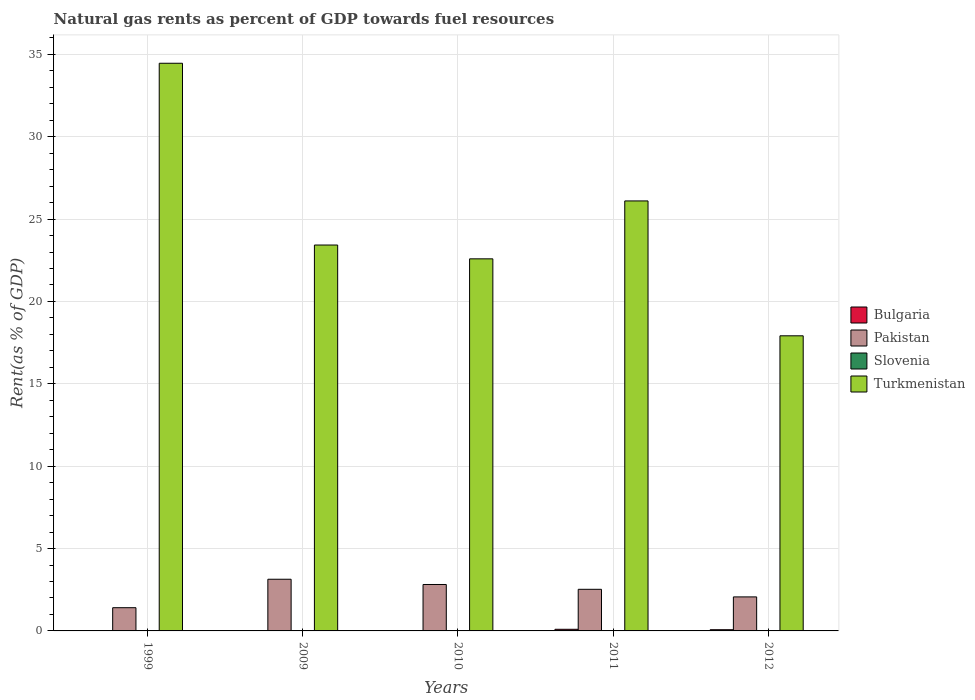How many different coloured bars are there?
Keep it short and to the point. 4. How many bars are there on the 5th tick from the left?
Your answer should be very brief. 4. What is the label of the 4th group of bars from the left?
Provide a short and direct response. 2011. What is the matural gas rent in Bulgaria in 1999?
Give a very brief answer. 0.01. Across all years, what is the maximum matural gas rent in Turkmenistan?
Keep it short and to the point. 34.46. Across all years, what is the minimum matural gas rent in Slovenia?
Give a very brief answer. 0. In which year was the matural gas rent in Slovenia maximum?
Your answer should be compact. 2010. In which year was the matural gas rent in Turkmenistan minimum?
Your answer should be very brief. 2012. What is the total matural gas rent in Slovenia in the graph?
Keep it short and to the point. 0. What is the difference between the matural gas rent in Pakistan in 2010 and that in 2011?
Offer a terse response. 0.29. What is the difference between the matural gas rent in Slovenia in 2010 and the matural gas rent in Bulgaria in 2012?
Offer a terse response. -0.07. What is the average matural gas rent in Bulgaria per year?
Give a very brief answer. 0.04. In the year 2010, what is the difference between the matural gas rent in Bulgaria and matural gas rent in Turkmenistan?
Offer a terse response. -22.57. In how many years, is the matural gas rent in Pakistan greater than 1 %?
Your response must be concise. 5. What is the ratio of the matural gas rent in Pakistan in 2010 to that in 2012?
Provide a short and direct response. 1.36. What is the difference between the highest and the second highest matural gas rent in Bulgaria?
Offer a terse response. 0.03. What is the difference between the highest and the lowest matural gas rent in Slovenia?
Keep it short and to the point. 0. What does the 3rd bar from the left in 2012 represents?
Give a very brief answer. Slovenia. Are all the bars in the graph horizontal?
Your answer should be compact. No. How many years are there in the graph?
Your answer should be very brief. 5. What is the difference between two consecutive major ticks on the Y-axis?
Offer a terse response. 5. Are the values on the major ticks of Y-axis written in scientific E-notation?
Offer a very short reply. No. Does the graph contain grids?
Give a very brief answer. Yes. Where does the legend appear in the graph?
Your response must be concise. Center right. How are the legend labels stacked?
Your answer should be very brief. Vertical. What is the title of the graph?
Your answer should be very brief. Natural gas rents as percent of GDP towards fuel resources. What is the label or title of the Y-axis?
Make the answer very short. Rent(as % of GDP). What is the Rent(as % of GDP) in Bulgaria in 1999?
Provide a succinct answer. 0.01. What is the Rent(as % of GDP) in Pakistan in 1999?
Make the answer very short. 1.41. What is the Rent(as % of GDP) of Slovenia in 1999?
Your answer should be very brief. 0. What is the Rent(as % of GDP) of Turkmenistan in 1999?
Your response must be concise. 34.46. What is the Rent(as % of GDP) in Bulgaria in 2009?
Your answer should be very brief. 0. What is the Rent(as % of GDP) in Pakistan in 2009?
Your answer should be compact. 3.14. What is the Rent(as % of GDP) in Slovenia in 2009?
Ensure brevity in your answer.  0. What is the Rent(as % of GDP) of Turkmenistan in 2009?
Your response must be concise. 23.42. What is the Rent(as % of GDP) in Bulgaria in 2010?
Make the answer very short. 0.02. What is the Rent(as % of GDP) in Pakistan in 2010?
Keep it short and to the point. 2.82. What is the Rent(as % of GDP) of Slovenia in 2010?
Ensure brevity in your answer.  0. What is the Rent(as % of GDP) in Turkmenistan in 2010?
Your response must be concise. 22.59. What is the Rent(as % of GDP) of Bulgaria in 2011?
Give a very brief answer. 0.1. What is the Rent(as % of GDP) of Pakistan in 2011?
Offer a very short reply. 2.53. What is the Rent(as % of GDP) in Slovenia in 2011?
Your response must be concise. 0. What is the Rent(as % of GDP) in Turkmenistan in 2011?
Make the answer very short. 26.1. What is the Rent(as % of GDP) of Bulgaria in 2012?
Give a very brief answer. 0.07. What is the Rent(as % of GDP) of Pakistan in 2012?
Make the answer very short. 2.07. What is the Rent(as % of GDP) in Slovenia in 2012?
Provide a succinct answer. 0. What is the Rent(as % of GDP) of Turkmenistan in 2012?
Give a very brief answer. 17.91. Across all years, what is the maximum Rent(as % of GDP) of Bulgaria?
Your response must be concise. 0.1. Across all years, what is the maximum Rent(as % of GDP) of Pakistan?
Ensure brevity in your answer.  3.14. Across all years, what is the maximum Rent(as % of GDP) of Slovenia?
Provide a short and direct response. 0. Across all years, what is the maximum Rent(as % of GDP) of Turkmenistan?
Provide a short and direct response. 34.46. Across all years, what is the minimum Rent(as % of GDP) in Bulgaria?
Your answer should be compact. 0. Across all years, what is the minimum Rent(as % of GDP) of Pakistan?
Your response must be concise. 1.41. Across all years, what is the minimum Rent(as % of GDP) of Slovenia?
Offer a terse response. 0. Across all years, what is the minimum Rent(as % of GDP) of Turkmenistan?
Offer a very short reply. 17.91. What is the total Rent(as % of GDP) in Bulgaria in the graph?
Your answer should be very brief. 0.2. What is the total Rent(as % of GDP) in Pakistan in the graph?
Your response must be concise. 11.96. What is the total Rent(as % of GDP) in Slovenia in the graph?
Make the answer very short. 0. What is the total Rent(as % of GDP) in Turkmenistan in the graph?
Keep it short and to the point. 124.48. What is the difference between the Rent(as % of GDP) of Bulgaria in 1999 and that in 2009?
Your answer should be very brief. 0. What is the difference between the Rent(as % of GDP) of Pakistan in 1999 and that in 2009?
Keep it short and to the point. -1.73. What is the difference between the Rent(as % of GDP) in Slovenia in 1999 and that in 2009?
Your answer should be compact. 0. What is the difference between the Rent(as % of GDP) in Turkmenistan in 1999 and that in 2009?
Provide a succinct answer. 11.03. What is the difference between the Rent(as % of GDP) in Bulgaria in 1999 and that in 2010?
Offer a very short reply. -0.01. What is the difference between the Rent(as % of GDP) in Pakistan in 1999 and that in 2010?
Offer a very short reply. -1.41. What is the difference between the Rent(as % of GDP) of Slovenia in 1999 and that in 2010?
Make the answer very short. -0. What is the difference between the Rent(as % of GDP) in Turkmenistan in 1999 and that in 2010?
Offer a terse response. 11.87. What is the difference between the Rent(as % of GDP) of Bulgaria in 1999 and that in 2011?
Your response must be concise. -0.09. What is the difference between the Rent(as % of GDP) in Pakistan in 1999 and that in 2011?
Your answer should be compact. -1.12. What is the difference between the Rent(as % of GDP) in Slovenia in 1999 and that in 2011?
Make the answer very short. 0. What is the difference between the Rent(as % of GDP) in Turkmenistan in 1999 and that in 2011?
Provide a short and direct response. 8.36. What is the difference between the Rent(as % of GDP) in Bulgaria in 1999 and that in 2012?
Provide a short and direct response. -0.07. What is the difference between the Rent(as % of GDP) of Pakistan in 1999 and that in 2012?
Offer a very short reply. -0.66. What is the difference between the Rent(as % of GDP) in Slovenia in 1999 and that in 2012?
Give a very brief answer. 0. What is the difference between the Rent(as % of GDP) in Turkmenistan in 1999 and that in 2012?
Ensure brevity in your answer.  16.54. What is the difference between the Rent(as % of GDP) of Bulgaria in 2009 and that in 2010?
Your answer should be very brief. -0.01. What is the difference between the Rent(as % of GDP) of Pakistan in 2009 and that in 2010?
Provide a succinct answer. 0.32. What is the difference between the Rent(as % of GDP) in Slovenia in 2009 and that in 2010?
Offer a very short reply. -0. What is the difference between the Rent(as % of GDP) of Turkmenistan in 2009 and that in 2010?
Your answer should be compact. 0.84. What is the difference between the Rent(as % of GDP) of Bulgaria in 2009 and that in 2011?
Offer a very short reply. -0.1. What is the difference between the Rent(as % of GDP) in Pakistan in 2009 and that in 2011?
Offer a very short reply. 0.61. What is the difference between the Rent(as % of GDP) in Slovenia in 2009 and that in 2011?
Your answer should be compact. 0. What is the difference between the Rent(as % of GDP) of Turkmenistan in 2009 and that in 2011?
Keep it short and to the point. -2.68. What is the difference between the Rent(as % of GDP) in Bulgaria in 2009 and that in 2012?
Give a very brief answer. -0.07. What is the difference between the Rent(as % of GDP) of Pakistan in 2009 and that in 2012?
Your answer should be compact. 1.07. What is the difference between the Rent(as % of GDP) in Slovenia in 2009 and that in 2012?
Provide a short and direct response. 0. What is the difference between the Rent(as % of GDP) of Turkmenistan in 2009 and that in 2012?
Keep it short and to the point. 5.51. What is the difference between the Rent(as % of GDP) of Bulgaria in 2010 and that in 2011?
Provide a short and direct response. -0.08. What is the difference between the Rent(as % of GDP) of Pakistan in 2010 and that in 2011?
Offer a very short reply. 0.29. What is the difference between the Rent(as % of GDP) in Slovenia in 2010 and that in 2011?
Ensure brevity in your answer.  0. What is the difference between the Rent(as % of GDP) in Turkmenistan in 2010 and that in 2011?
Make the answer very short. -3.52. What is the difference between the Rent(as % of GDP) of Bulgaria in 2010 and that in 2012?
Your answer should be compact. -0.06. What is the difference between the Rent(as % of GDP) in Pakistan in 2010 and that in 2012?
Ensure brevity in your answer.  0.75. What is the difference between the Rent(as % of GDP) in Slovenia in 2010 and that in 2012?
Provide a succinct answer. 0. What is the difference between the Rent(as % of GDP) of Turkmenistan in 2010 and that in 2012?
Give a very brief answer. 4.67. What is the difference between the Rent(as % of GDP) of Bulgaria in 2011 and that in 2012?
Your response must be concise. 0.03. What is the difference between the Rent(as % of GDP) of Pakistan in 2011 and that in 2012?
Give a very brief answer. 0.46. What is the difference between the Rent(as % of GDP) in Turkmenistan in 2011 and that in 2012?
Make the answer very short. 8.19. What is the difference between the Rent(as % of GDP) of Bulgaria in 1999 and the Rent(as % of GDP) of Pakistan in 2009?
Ensure brevity in your answer.  -3.13. What is the difference between the Rent(as % of GDP) in Bulgaria in 1999 and the Rent(as % of GDP) in Slovenia in 2009?
Offer a very short reply. 0.01. What is the difference between the Rent(as % of GDP) of Bulgaria in 1999 and the Rent(as % of GDP) of Turkmenistan in 2009?
Provide a short and direct response. -23.42. What is the difference between the Rent(as % of GDP) in Pakistan in 1999 and the Rent(as % of GDP) in Slovenia in 2009?
Provide a short and direct response. 1.41. What is the difference between the Rent(as % of GDP) in Pakistan in 1999 and the Rent(as % of GDP) in Turkmenistan in 2009?
Make the answer very short. -22.01. What is the difference between the Rent(as % of GDP) of Slovenia in 1999 and the Rent(as % of GDP) of Turkmenistan in 2009?
Provide a succinct answer. -23.42. What is the difference between the Rent(as % of GDP) in Bulgaria in 1999 and the Rent(as % of GDP) in Pakistan in 2010?
Provide a short and direct response. -2.81. What is the difference between the Rent(as % of GDP) in Bulgaria in 1999 and the Rent(as % of GDP) in Slovenia in 2010?
Keep it short and to the point. 0.01. What is the difference between the Rent(as % of GDP) of Bulgaria in 1999 and the Rent(as % of GDP) of Turkmenistan in 2010?
Make the answer very short. -22.58. What is the difference between the Rent(as % of GDP) of Pakistan in 1999 and the Rent(as % of GDP) of Slovenia in 2010?
Give a very brief answer. 1.41. What is the difference between the Rent(as % of GDP) in Pakistan in 1999 and the Rent(as % of GDP) in Turkmenistan in 2010?
Provide a short and direct response. -21.18. What is the difference between the Rent(as % of GDP) of Slovenia in 1999 and the Rent(as % of GDP) of Turkmenistan in 2010?
Offer a very short reply. -22.58. What is the difference between the Rent(as % of GDP) in Bulgaria in 1999 and the Rent(as % of GDP) in Pakistan in 2011?
Keep it short and to the point. -2.52. What is the difference between the Rent(as % of GDP) in Bulgaria in 1999 and the Rent(as % of GDP) in Slovenia in 2011?
Provide a succinct answer. 0.01. What is the difference between the Rent(as % of GDP) in Bulgaria in 1999 and the Rent(as % of GDP) in Turkmenistan in 2011?
Ensure brevity in your answer.  -26.09. What is the difference between the Rent(as % of GDP) of Pakistan in 1999 and the Rent(as % of GDP) of Slovenia in 2011?
Ensure brevity in your answer.  1.41. What is the difference between the Rent(as % of GDP) in Pakistan in 1999 and the Rent(as % of GDP) in Turkmenistan in 2011?
Make the answer very short. -24.69. What is the difference between the Rent(as % of GDP) of Slovenia in 1999 and the Rent(as % of GDP) of Turkmenistan in 2011?
Ensure brevity in your answer.  -26.1. What is the difference between the Rent(as % of GDP) of Bulgaria in 1999 and the Rent(as % of GDP) of Pakistan in 2012?
Give a very brief answer. -2.06. What is the difference between the Rent(as % of GDP) of Bulgaria in 1999 and the Rent(as % of GDP) of Slovenia in 2012?
Offer a terse response. 0.01. What is the difference between the Rent(as % of GDP) of Bulgaria in 1999 and the Rent(as % of GDP) of Turkmenistan in 2012?
Your response must be concise. -17.91. What is the difference between the Rent(as % of GDP) in Pakistan in 1999 and the Rent(as % of GDP) in Slovenia in 2012?
Keep it short and to the point. 1.41. What is the difference between the Rent(as % of GDP) of Pakistan in 1999 and the Rent(as % of GDP) of Turkmenistan in 2012?
Provide a succinct answer. -16.5. What is the difference between the Rent(as % of GDP) in Slovenia in 1999 and the Rent(as % of GDP) in Turkmenistan in 2012?
Give a very brief answer. -17.91. What is the difference between the Rent(as % of GDP) of Bulgaria in 2009 and the Rent(as % of GDP) of Pakistan in 2010?
Offer a very short reply. -2.81. What is the difference between the Rent(as % of GDP) of Bulgaria in 2009 and the Rent(as % of GDP) of Slovenia in 2010?
Your answer should be compact. 0. What is the difference between the Rent(as % of GDP) in Bulgaria in 2009 and the Rent(as % of GDP) in Turkmenistan in 2010?
Offer a very short reply. -22.58. What is the difference between the Rent(as % of GDP) in Pakistan in 2009 and the Rent(as % of GDP) in Slovenia in 2010?
Keep it short and to the point. 3.13. What is the difference between the Rent(as % of GDP) in Pakistan in 2009 and the Rent(as % of GDP) in Turkmenistan in 2010?
Your response must be concise. -19.45. What is the difference between the Rent(as % of GDP) in Slovenia in 2009 and the Rent(as % of GDP) in Turkmenistan in 2010?
Provide a succinct answer. -22.59. What is the difference between the Rent(as % of GDP) of Bulgaria in 2009 and the Rent(as % of GDP) of Pakistan in 2011?
Offer a terse response. -2.52. What is the difference between the Rent(as % of GDP) in Bulgaria in 2009 and the Rent(as % of GDP) in Slovenia in 2011?
Offer a very short reply. 0. What is the difference between the Rent(as % of GDP) in Bulgaria in 2009 and the Rent(as % of GDP) in Turkmenistan in 2011?
Provide a short and direct response. -26.1. What is the difference between the Rent(as % of GDP) of Pakistan in 2009 and the Rent(as % of GDP) of Slovenia in 2011?
Offer a terse response. 3.14. What is the difference between the Rent(as % of GDP) of Pakistan in 2009 and the Rent(as % of GDP) of Turkmenistan in 2011?
Offer a very short reply. -22.96. What is the difference between the Rent(as % of GDP) in Slovenia in 2009 and the Rent(as % of GDP) in Turkmenistan in 2011?
Your answer should be very brief. -26.1. What is the difference between the Rent(as % of GDP) of Bulgaria in 2009 and the Rent(as % of GDP) of Pakistan in 2012?
Ensure brevity in your answer.  -2.06. What is the difference between the Rent(as % of GDP) in Bulgaria in 2009 and the Rent(as % of GDP) in Slovenia in 2012?
Your answer should be very brief. 0. What is the difference between the Rent(as % of GDP) in Bulgaria in 2009 and the Rent(as % of GDP) in Turkmenistan in 2012?
Keep it short and to the point. -17.91. What is the difference between the Rent(as % of GDP) of Pakistan in 2009 and the Rent(as % of GDP) of Slovenia in 2012?
Offer a very short reply. 3.14. What is the difference between the Rent(as % of GDP) in Pakistan in 2009 and the Rent(as % of GDP) in Turkmenistan in 2012?
Make the answer very short. -14.78. What is the difference between the Rent(as % of GDP) in Slovenia in 2009 and the Rent(as % of GDP) in Turkmenistan in 2012?
Offer a terse response. -17.91. What is the difference between the Rent(as % of GDP) of Bulgaria in 2010 and the Rent(as % of GDP) of Pakistan in 2011?
Your answer should be compact. -2.51. What is the difference between the Rent(as % of GDP) of Bulgaria in 2010 and the Rent(as % of GDP) of Slovenia in 2011?
Offer a terse response. 0.02. What is the difference between the Rent(as % of GDP) in Bulgaria in 2010 and the Rent(as % of GDP) in Turkmenistan in 2011?
Your answer should be very brief. -26.08. What is the difference between the Rent(as % of GDP) in Pakistan in 2010 and the Rent(as % of GDP) in Slovenia in 2011?
Your response must be concise. 2.82. What is the difference between the Rent(as % of GDP) in Pakistan in 2010 and the Rent(as % of GDP) in Turkmenistan in 2011?
Make the answer very short. -23.28. What is the difference between the Rent(as % of GDP) of Slovenia in 2010 and the Rent(as % of GDP) of Turkmenistan in 2011?
Offer a very short reply. -26.1. What is the difference between the Rent(as % of GDP) of Bulgaria in 2010 and the Rent(as % of GDP) of Pakistan in 2012?
Your answer should be very brief. -2.05. What is the difference between the Rent(as % of GDP) of Bulgaria in 2010 and the Rent(as % of GDP) of Slovenia in 2012?
Your answer should be compact. 0.02. What is the difference between the Rent(as % of GDP) in Bulgaria in 2010 and the Rent(as % of GDP) in Turkmenistan in 2012?
Ensure brevity in your answer.  -17.9. What is the difference between the Rent(as % of GDP) in Pakistan in 2010 and the Rent(as % of GDP) in Slovenia in 2012?
Offer a very short reply. 2.82. What is the difference between the Rent(as % of GDP) in Pakistan in 2010 and the Rent(as % of GDP) in Turkmenistan in 2012?
Keep it short and to the point. -15.09. What is the difference between the Rent(as % of GDP) of Slovenia in 2010 and the Rent(as % of GDP) of Turkmenistan in 2012?
Provide a short and direct response. -17.91. What is the difference between the Rent(as % of GDP) in Bulgaria in 2011 and the Rent(as % of GDP) in Pakistan in 2012?
Your response must be concise. -1.97. What is the difference between the Rent(as % of GDP) in Bulgaria in 2011 and the Rent(as % of GDP) in Slovenia in 2012?
Your answer should be very brief. 0.1. What is the difference between the Rent(as % of GDP) in Bulgaria in 2011 and the Rent(as % of GDP) in Turkmenistan in 2012?
Give a very brief answer. -17.81. What is the difference between the Rent(as % of GDP) of Pakistan in 2011 and the Rent(as % of GDP) of Slovenia in 2012?
Provide a succinct answer. 2.53. What is the difference between the Rent(as % of GDP) in Pakistan in 2011 and the Rent(as % of GDP) in Turkmenistan in 2012?
Offer a terse response. -15.39. What is the difference between the Rent(as % of GDP) of Slovenia in 2011 and the Rent(as % of GDP) of Turkmenistan in 2012?
Ensure brevity in your answer.  -17.91. What is the average Rent(as % of GDP) of Bulgaria per year?
Your response must be concise. 0.04. What is the average Rent(as % of GDP) in Pakistan per year?
Ensure brevity in your answer.  2.39. What is the average Rent(as % of GDP) of Slovenia per year?
Make the answer very short. 0. What is the average Rent(as % of GDP) of Turkmenistan per year?
Your answer should be very brief. 24.9. In the year 1999, what is the difference between the Rent(as % of GDP) in Bulgaria and Rent(as % of GDP) in Pakistan?
Your answer should be compact. -1.4. In the year 1999, what is the difference between the Rent(as % of GDP) of Bulgaria and Rent(as % of GDP) of Slovenia?
Offer a very short reply. 0.01. In the year 1999, what is the difference between the Rent(as % of GDP) of Bulgaria and Rent(as % of GDP) of Turkmenistan?
Keep it short and to the point. -34.45. In the year 1999, what is the difference between the Rent(as % of GDP) in Pakistan and Rent(as % of GDP) in Slovenia?
Provide a short and direct response. 1.41. In the year 1999, what is the difference between the Rent(as % of GDP) in Pakistan and Rent(as % of GDP) in Turkmenistan?
Offer a very short reply. -33.05. In the year 1999, what is the difference between the Rent(as % of GDP) in Slovenia and Rent(as % of GDP) in Turkmenistan?
Ensure brevity in your answer.  -34.46. In the year 2009, what is the difference between the Rent(as % of GDP) of Bulgaria and Rent(as % of GDP) of Pakistan?
Provide a short and direct response. -3.13. In the year 2009, what is the difference between the Rent(as % of GDP) of Bulgaria and Rent(as % of GDP) of Slovenia?
Make the answer very short. 0. In the year 2009, what is the difference between the Rent(as % of GDP) of Bulgaria and Rent(as % of GDP) of Turkmenistan?
Ensure brevity in your answer.  -23.42. In the year 2009, what is the difference between the Rent(as % of GDP) of Pakistan and Rent(as % of GDP) of Slovenia?
Provide a succinct answer. 3.14. In the year 2009, what is the difference between the Rent(as % of GDP) of Pakistan and Rent(as % of GDP) of Turkmenistan?
Keep it short and to the point. -20.29. In the year 2009, what is the difference between the Rent(as % of GDP) in Slovenia and Rent(as % of GDP) in Turkmenistan?
Your response must be concise. -23.42. In the year 2010, what is the difference between the Rent(as % of GDP) in Bulgaria and Rent(as % of GDP) in Pakistan?
Offer a terse response. -2.8. In the year 2010, what is the difference between the Rent(as % of GDP) of Bulgaria and Rent(as % of GDP) of Slovenia?
Your answer should be very brief. 0.02. In the year 2010, what is the difference between the Rent(as % of GDP) in Bulgaria and Rent(as % of GDP) in Turkmenistan?
Ensure brevity in your answer.  -22.57. In the year 2010, what is the difference between the Rent(as % of GDP) in Pakistan and Rent(as % of GDP) in Slovenia?
Your answer should be compact. 2.82. In the year 2010, what is the difference between the Rent(as % of GDP) of Pakistan and Rent(as % of GDP) of Turkmenistan?
Ensure brevity in your answer.  -19.77. In the year 2010, what is the difference between the Rent(as % of GDP) of Slovenia and Rent(as % of GDP) of Turkmenistan?
Your answer should be very brief. -22.58. In the year 2011, what is the difference between the Rent(as % of GDP) in Bulgaria and Rent(as % of GDP) in Pakistan?
Offer a very short reply. -2.43. In the year 2011, what is the difference between the Rent(as % of GDP) of Bulgaria and Rent(as % of GDP) of Slovenia?
Offer a very short reply. 0.1. In the year 2011, what is the difference between the Rent(as % of GDP) in Bulgaria and Rent(as % of GDP) in Turkmenistan?
Your answer should be compact. -26. In the year 2011, what is the difference between the Rent(as % of GDP) in Pakistan and Rent(as % of GDP) in Slovenia?
Your response must be concise. 2.53. In the year 2011, what is the difference between the Rent(as % of GDP) of Pakistan and Rent(as % of GDP) of Turkmenistan?
Your answer should be compact. -23.58. In the year 2011, what is the difference between the Rent(as % of GDP) in Slovenia and Rent(as % of GDP) in Turkmenistan?
Your answer should be compact. -26.1. In the year 2012, what is the difference between the Rent(as % of GDP) in Bulgaria and Rent(as % of GDP) in Pakistan?
Keep it short and to the point. -1.99. In the year 2012, what is the difference between the Rent(as % of GDP) in Bulgaria and Rent(as % of GDP) in Slovenia?
Give a very brief answer. 0.07. In the year 2012, what is the difference between the Rent(as % of GDP) of Bulgaria and Rent(as % of GDP) of Turkmenistan?
Provide a short and direct response. -17.84. In the year 2012, what is the difference between the Rent(as % of GDP) of Pakistan and Rent(as % of GDP) of Slovenia?
Offer a terse response. 2.06. In the year 2012, what is the difference between the Rent(as % of GDP) in Pakistan and Rent(as % of GDP) in Turkmenistan?
Give a very brief answer. -15.85. In the year 2012, what is the difference between the Rent(as % of GDP) in Slovenia and Rent(as % of GDP) in Turkmenistan?
Your response must be concise. -17.91. What is the ratio of the Rent(as % of GDP) in Bulgaria in 1999 to that in 2009?
Make the answer very short. 1.88. What is the ratio of the Rent(as % of GDP) in Pakistan in 1999 to that in 2009?
Offer a terse response. 0.45. What is the ratio of the Rent(as % of GDP) in Slovenia in 1999 to that in 2009?
Provide a succinct answer. 1.32. What is the ratio of the Rent(as % of GDP) in Turkmenistan in 1999 to that in 2009?
Your answer should be compact. 1.47. What is the ratio of the Rent(as % of GDP) in Bulgaria in 1999 to that in 2010?
Your answer should be compact. 0.44. What is the ratio of the Rent(as % of GDP) in Pakistan in 1999 to that in 2010?
Make the answer very short. 0.5. What is the ratio of the Rent(as % of GDP) of Slovenia in 1999 to that in 2010?
Keep it short and to the point. 0.6. What is the ratio of the Rent(as % of GDP) in Turkmenistan in 1999 to that in 2010?
Offer a very short reply. 1.53. What is the ratio of the Rent(as % of GDP) in Bulgaria in 1999 to that in 2011?
Give a very brief answer. 0.08. What is the ratio of the Rent(as % of GDP) in Pakistan in 1999 to that in 2011?
Keep it short and to the point. 0.56. What is the ratio of the Rent(as % of GDP) in Slovenia in 1999 to that in 2011?
Offer a terse response. 2.05. What is the ratio of the Rent(as % of GDP) in Turkmenistan in 1999 to that in 2011?
Your response must be concise. 1.32. What is the ratio of the Rent(as % of GDP) in Bulgaria in 1999 to that in 2012?
Make the answer very short. 0.11. What is the ratio of the Rent(as % of GDP) in Pakistan in 1999 to that in 2012?
Offer a terse response. 0.68. What is the ratio of the Rent(as % of GDP) in Slovenia in 1999 to that in 2012?
Ensure brevity in your answer.  2.34. What is the ratio of the Rent(as % of GDP) of Turkmenistan in 1999 to that in 2012?
Make the answer very short. 1.92. What is the ratio of the Rent(as % of GDP) of Bulgaria in 2009 to that in 2010?
Your answer should be compact. 0.24. What is the ratio of the Rent(as % of GDP) in Pakistan in 2009 to that in 2010?
Offer a very short reply. 1.11. What is the ratio of the Rent(as % of GDP) in Slovenia in 2009 to that in 2010?
Provide a succinct answer. 0.45. What is the ratio of the Rent(as % of GDP) in Turkmenistan in 2009 to that in 2010?
Make the answer very short. 1.04. What is the ratio of the Rent(as % of GDP) in Bulgaria in 2009 to that in 2011?
Provide a succinct answer. 0.04. What is the ratio of the Rent(as % of GDP) of Pakistan in 2009 to that in 2011?
Offer a terse response. 1.24. What is the ratio of the Rent(as % of GDP) in Slovenia in 2009 to that in 2011?
Give a very brief answer. 1.55. What is the ratio of the Rent(as % of GDP) of Turkmenistan in 2009 to that in 2011?
Ensure brevity in your answer.  0.9. What is the ratio of the Rent(as % of GDP) of Bulgaria in 2009 to that in 2012?
Offer a very short reply. 0.06. What is the ratio of the Rent(as % of GDP) in Pakistan in 2009 to that in 2012?
Keep it short and to the point. 1.52. What is the ratio of the Rent(as % of GDP) in Slovenia in 2009 to that in 2012?
Your answer should be very brief. 1.78. What is the ratio of the Rent(as % of GDP) in Turkmenistan in 2009 to that in 2012?
Ensure brevity in your answer.  1.31. What is the ratio of the Rent(as % of GDP) in Bulgaria in 2010 to that in 2011?
Your answer should be compact. 0.18. What is the ratio of the Rent(as % of GDP) in Pakistan in 2010 to that in 2011?
Provide a short and direct response. 1.12. What is the ratio of the Rent(as % of GDP) of Slovenia in 2010 to that in 2011?
Your response must be concise. 3.43. What is the ratio of the Rent(as % of GDP) of Turkmenistan in 2010 to that in 2011?
Ensure brevity in your answer.  0.87. What is the ratio of the Rent(as % of GDP) of Bulgaria in 2010 to that in 2012?
Make the answer very short. 0.24. What is the ratio of the Rent(as % of GDP) in Pakistan in 2010 to that in 2012?
Your answer should be compact. 1.36. What is the ratio of the Rent(as % of GDP) of Slovenia in 2010 to that in 2012?
Make the answer very short. 3.93. What is the ratio of the Rent(as % of GDP) of Turkmenistan in 2010 to that in 2012?
Provide a short and direct response. 1.26. What is the ratio of the Rent(as % of GDP) of Bulgaria in 2011 to that in 2012?
Provide a short and direct response. 1.36. What is the ratio of the Rent(as % of GDP) of Pakistan in 2011 to that in 2012?
Your answer should be compact. 1.22. What is the ratio of the Rent(as % of GDP) of Slovenia in 2011 to that in 2012?
Give a very brief answer. 1.14. What is the ratio of the Rent(as % of GDP) in Turkmenistan in 2011 to that in 2012?
Ensure brevity in your answer.  1.46. What is the difference between the highest and the second highest Rent(as % of GDP) in Bulgaria?
Give a very brief answer. 0.03. What is the difference between the highest and the second highest Rent(as % of GDP) in Pakistan?
Keep it short and to the point. 0.32. What is the difference between the highest and the second highest Rent(as % of GDP) in Slovenia?
Offer a terse response. 0. What is the difference between the highest and the second highest Rent(as % of GDP) of Turkmenistan?
Ensure brevity in your answer.  8.36. What is the difference between the highest and the lowest Rent(as % of GDP) in Bulgaria?
Give a very brief answer. 0.1. What is the difference between the highest and the lowest Rent(as % of GDP) in Pakistan?
Provide a short and direct response. 1.73. What is the difference between the highest and the lowest Rent(as % of GDP) of Slovenia?
Ensure brevity in your answer.  0. What is the difference between the highest and the lowest Rent(as % of GDP) of Turkmenistan?
Keep it short and to the point. 16.54. 